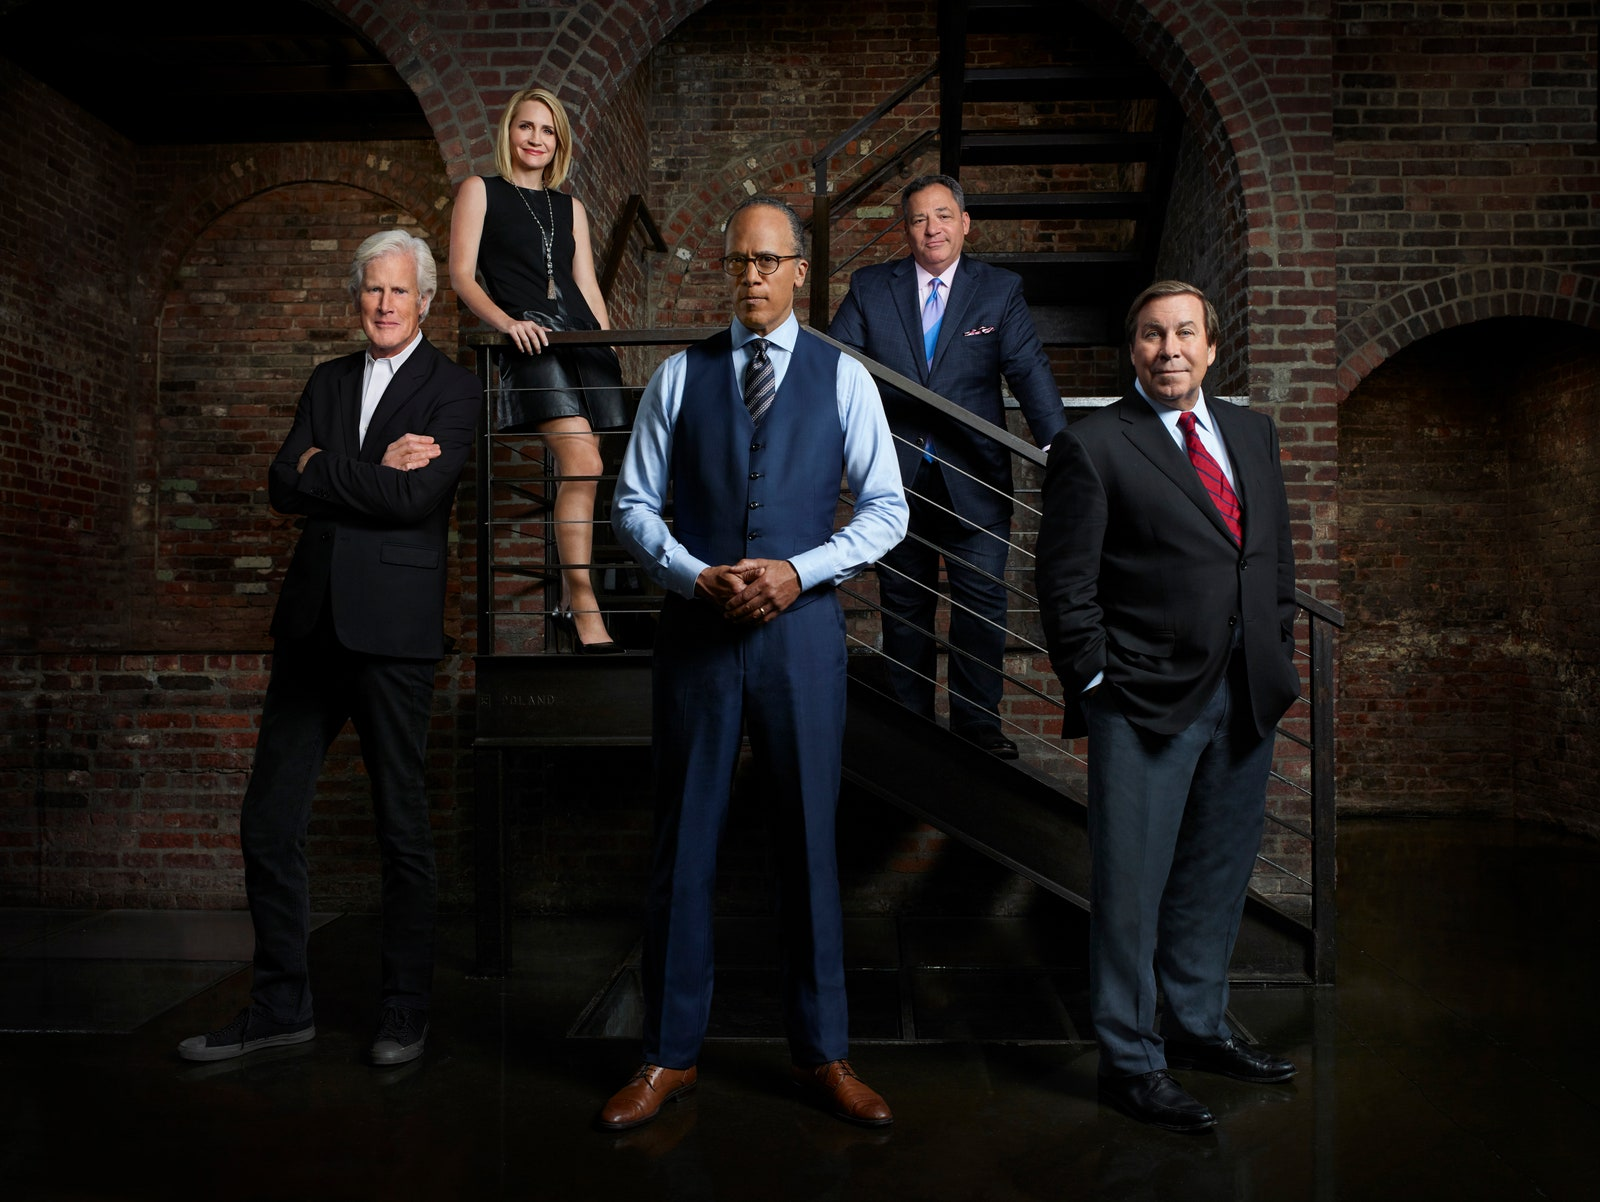Considering the attire and positioning of these individuals in this setting, what might be their professional relationship or the nature of the event for which they have gathered? The individuals are dressed in formal attire, which suggests professionalism and a significant occasion. The men are wearing suits and ties, and the woman is in a smart, stylish dress, indicating that they might be part of an executive team or senior management. The brick wall background and the strategic arrangement in the photograph suggest a corporate setting, possibly for a professional profile shoot, company website, or promotional material. The deliberate positioning also hints at an organized hierarchy or team dynamics, with a focus on showcasing leadership and unity. 